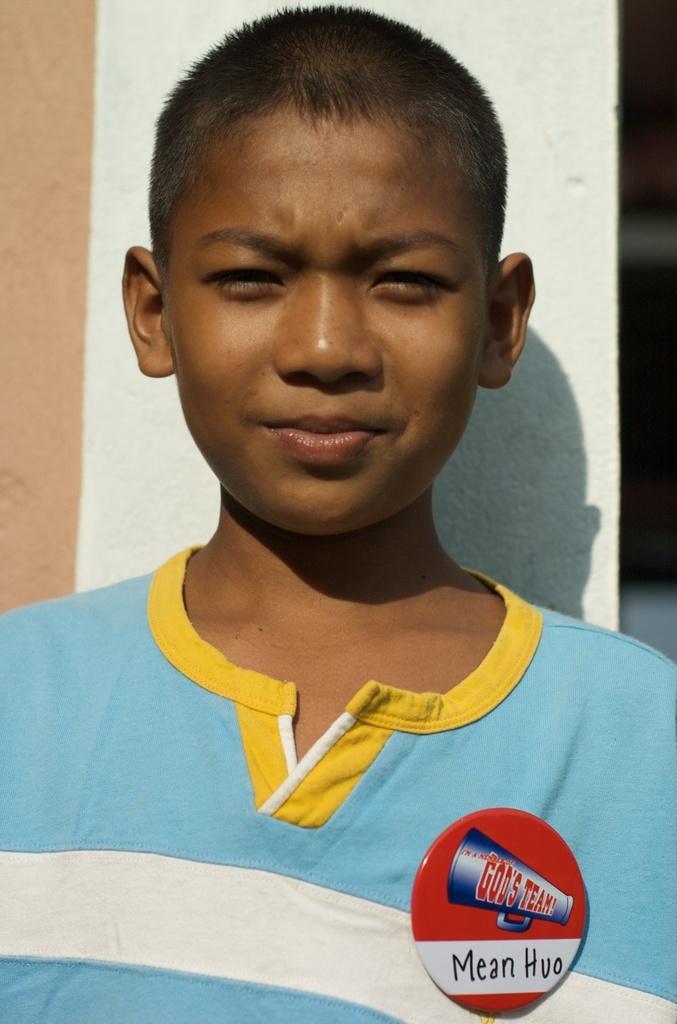Can you describe this image briefly? This picture describe about the small boy wearing a blue color t-shirt is smiling and giving a pose into the camera. Behind there is a white color wall. 